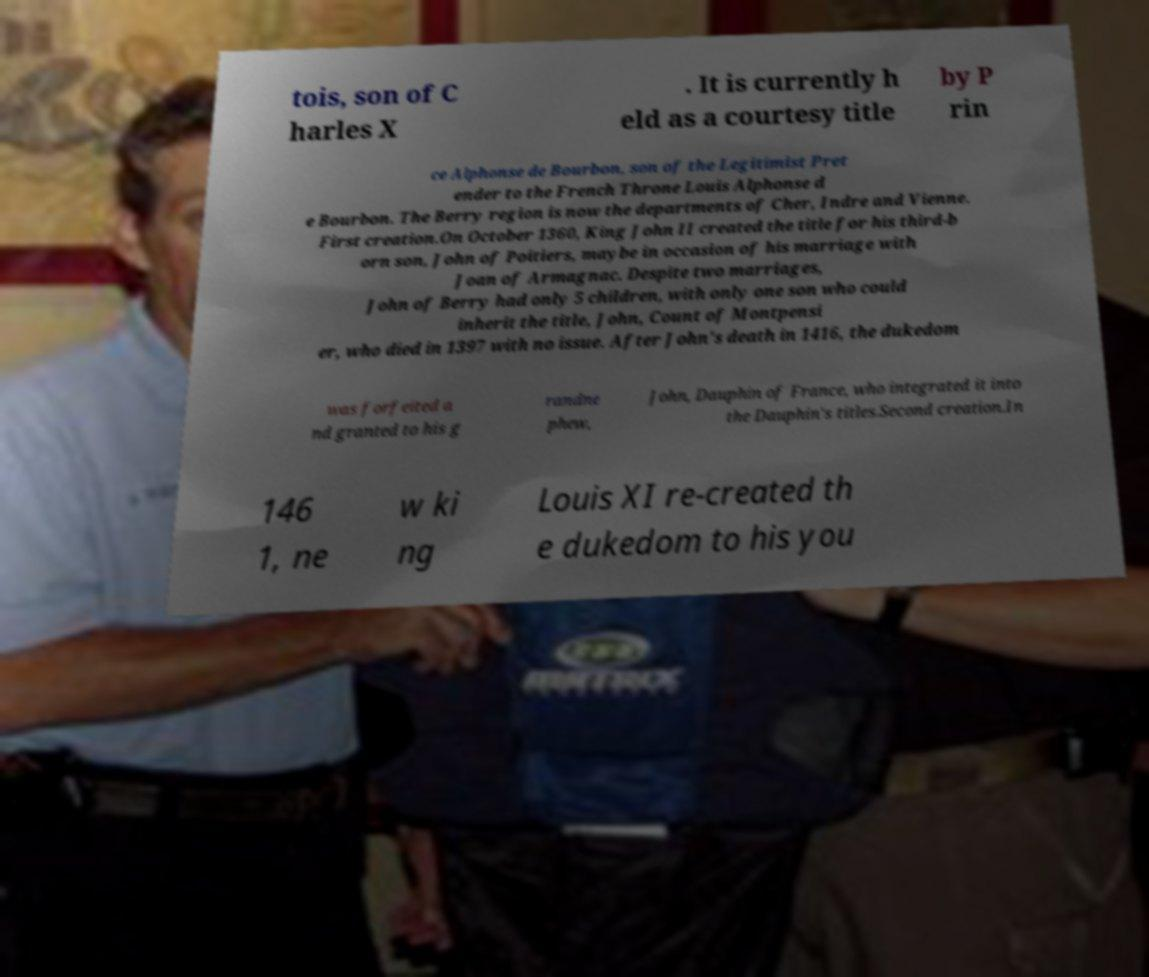Could you extract and type out the text from this image? tois, son of C harles X . It is currently h eld as a courtesy title by P rin ce Alphonse de Bourbon, son of the Legitimist Pret ender to the French Throne Louis Alphonse d e Bourbon. The Berry region is now the departments of Cher, Indre and Vienne. First creation.On October 1360, King John II created the title for his third-b orn son, John of Poitiers, maybe in occasion of his marriage with Joan of Armagnac. Despite two marriages, John of Berry had only 5 children, with only one son who could inherit the title, John, Count of Montpensi er, who died in 1397 with no issue. After John's death in 1416, the dukedom was forfeited a nd granted to his g randne phew, John, Dauphin of France, who integrated it into the Dauphin's titles.Second creation.In 146 1, ne w ki ng Louis XI re-created th e dukedom to his you 